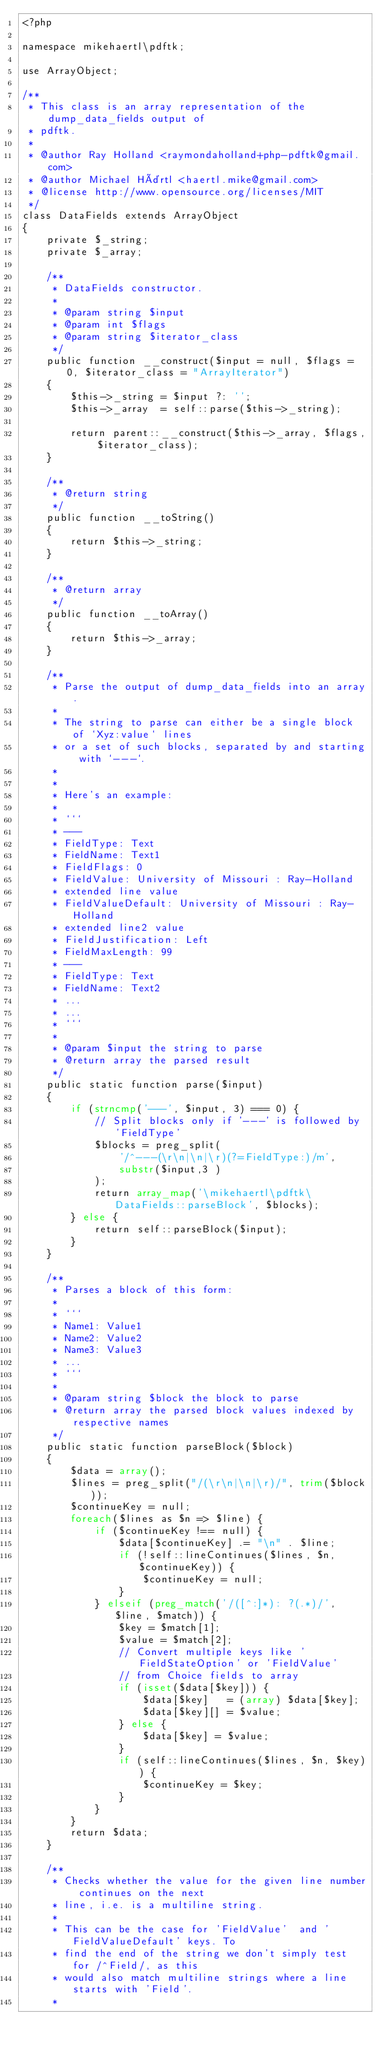<code> <loc_0><loc_0><loc_500><loc_500><_PHP_><?php

namespace mikehaertl\pdftk;

use ArrayObject;

/**
 * This class is an array representation of the dump_data_fields output of
 * pdftk.
 *
 * @author Ray Holland <raymondaholland+php-pdftk@gmail.com>
 * @author Michael Härtl <haertl.mike@gmail.com>
 * @license http://www.opensource.org/licenses/MIT
 */
class DataFields extends ArrayObject
{
    private $_string;
    private $_array;

    /**
     * DataFields constructor.
     *
     * @param string $input
     * @param int $flags
     * @param string $iterator_class
     */
    public function __construct($input = null, $flags = 0, $iterator_class = "ArrayIterator")
    {
        $this->_string = $input ?: '';
        $this->_array  = self::parse($this->_string);

        return parent::__construct($this->_array, $flags, $iterator_class);
    }

    /**
     * @return string
     */
    public function __toString()
    {
        return $this->_string;
    }

    /**
     * @return array
     */
    public function __toArray()
    {
        return $this->_array;
    }

    /**
     * Parse the output of dump_data_fields into an array.
     *
     * The string to parse can either be a single block of `Xyz:value` lines
     * or a set of such blocks, separated by and starting with `---`.
     *
     *
     * Here's an example:
     *
     * ```
     * ---
     * FieldType: Text
     * FieldName: Text1
     * FieldFlags: 0
     * FieldValue: University of Missouri : Ray-Holland
     * extended line value
     * FieldValueDefault: University of Missouri : Ray-Holland
     * extended line2 value
     * FieldJustification: Left
     * FieldMaxLength: 99
     * ---
     * FieldType: Text
     * FieldName: Text2
     * ...
     * ...
     * ```
     *
     * @param $input the string to parse
     * @return array the parsed result
     */
    public static function parse($input)
    {
        if (strncmp('---', $input, 3) === 0) {
            // Split blocks only if '---' is followed by 'FieldType'
            $blocks = preg_split(
                '/^---(\r\n|\n|\r)(?=FieldType:)/m',
                substr($input,3 )
            );
            return array_map('\mikehaertl\pdftk\DataFields::parseBlock', $blocks);
        } else {
            return self::parseBlock($input);
        }
    }

    /**
     * Parses a block of this form:
     *
     * ```
     * Name1: Value1
     * Name2: Value2
     * Name3: Value3
     * ...
     * ```
     *
     * @param string $block the block to parse
     * @return array the parsed block values indexed by respective names
     */
    public static function parseBlock($block)
    {
        $data = array();
        $lines = preg_split("/(\r\n|\n|\r)/", trim($block));
        $continueKey = null;
        foreach($lines as $n => $line) {
            if ($continueKey !== null) {
                $data[$continueKey] .= "\n" . $line;
                if (!self::lineContinues($lines, $n, $continueKey)) {
                    $continueKey = null;
                }
            } elseif (preg_match('/([^:]*): ?(.*)/', $line, $match)) {
                $key = $match[1];
                $value = $match[2];
                // Convert multiple keys like 'FieldStateOption' or 'FieldValue'
                // from Choice fields to array
                if (isset($data[$key])) {
                    $data[$key]   = (array) $data[$key];
                    $data[$key][] = $value;
                } else {
                    $data[$key] = $value;
                }
                if (self::lineContinues($lines, $n, $key)) {
                    $continueKey = $key;
                }
            }
        }
        return $data;
    }

    /**
     * Checks whether the value for the given line number continues on the next
     * line, i.e. is a multiline string.
     *
     * This can be the case for 'FieldValue'  and 'FieldValueDefault' keys. To
     * find the end of the string we don't simply test for /^Field/, as this
     * would also match multiline strings where a line starts with 'Field'.
     *</code> 